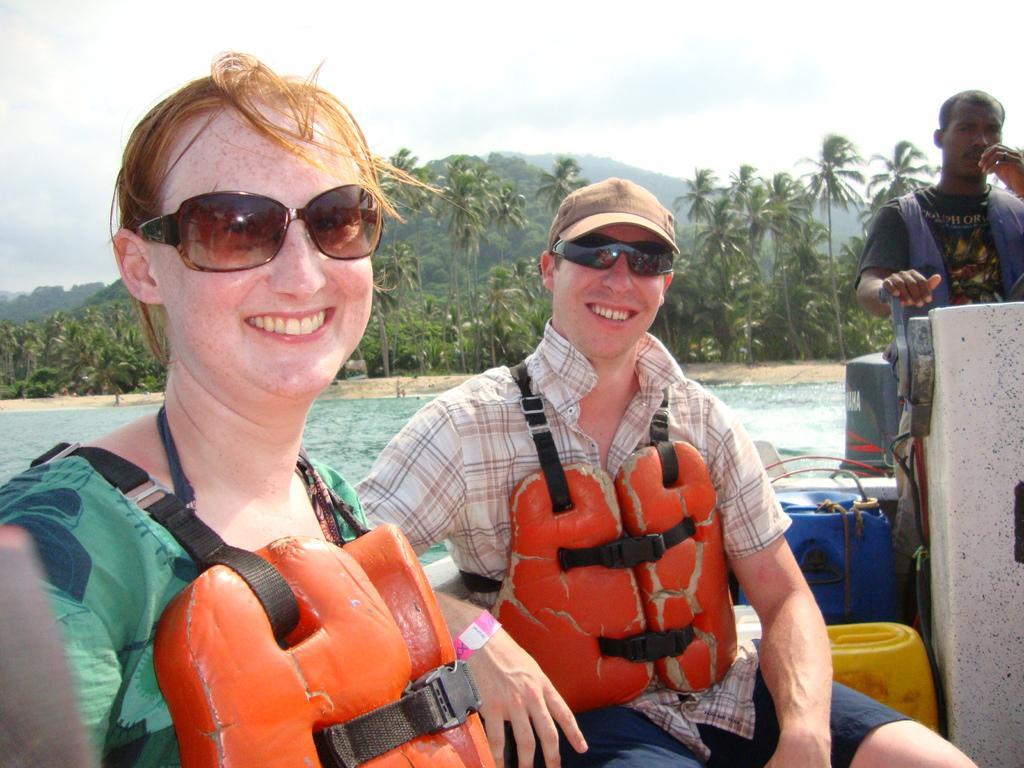How would you summarize this image in a sentence or two? In the picture we can see a man and a woman sitting in the boat and smiling and they are in live jackets and beside them we can see a man sailing the boat and in the background we can see water surface and behind it we can see full of coconut trees and behind it we can see hills and the sky. 